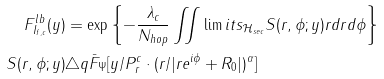<formula> <loc_0><loc_0><loc_500><loc_500>F ^ { l b } _ { I _ { f , c } } ( y ) & = \exp \left \{ - \frac { \lambda _ { c } } { N _ { h o p } } \iint \lim i t s _ { \mathcal { H } _ { s e c } } S ( r , \phi ; y ) r d r d \phi \right \} \\ S ( r , \phi ; y ) & \triangle q \bar { F } _ { \Psi } [ y / P _ { r } ^ { c } \cdot ( r / | r e ^ { i \phi } + R _ { 0 } | ) ^ { \alpha } ]</formula> 